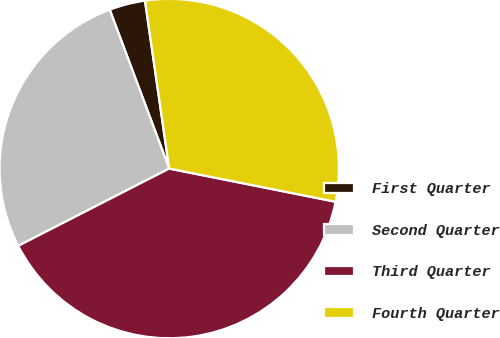<chart> <loc_0><loc_0><loc_500><loc_500><pie_chart><fcel>First Quarter<fcel>Second Quarter<fcel>Third Quarter<fcel>Fourth Quarter<nl><fcel>3.42%<fcel>26.83%<fcel>39.34%<fcel>30.42%<nl></chart> 